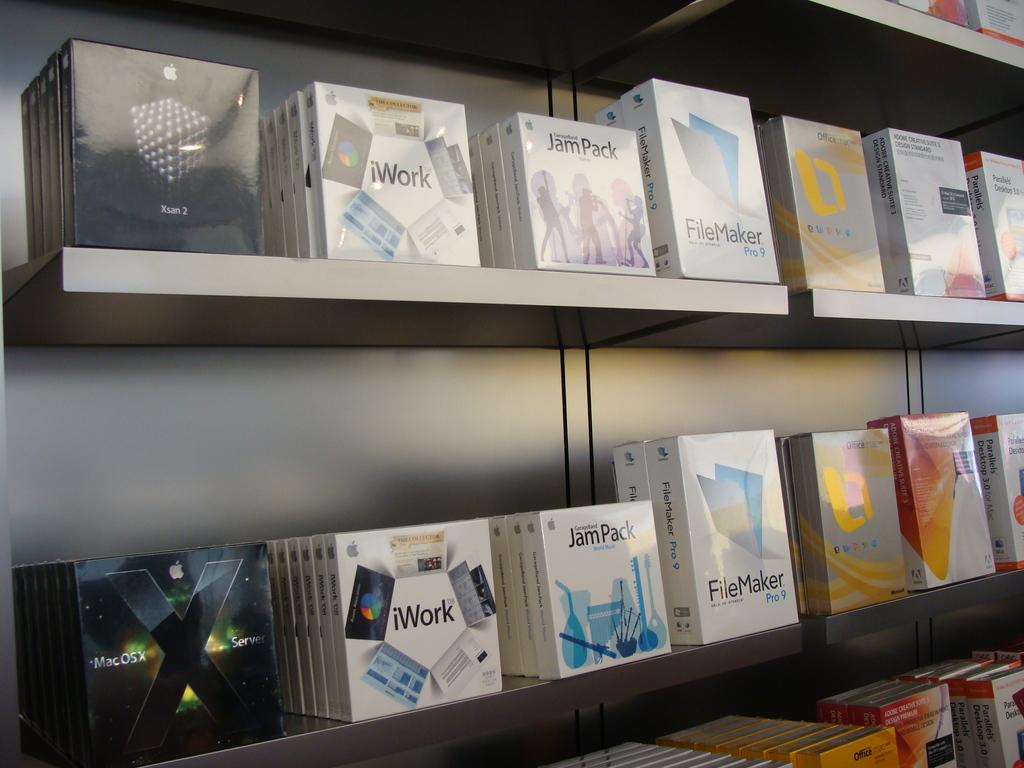What is the name of the 2nd item on the 2nd shelf?
Provide a succinct answer. Iwork. Which brand is the first item on the bottom?
Make the answer very short. Apple. 